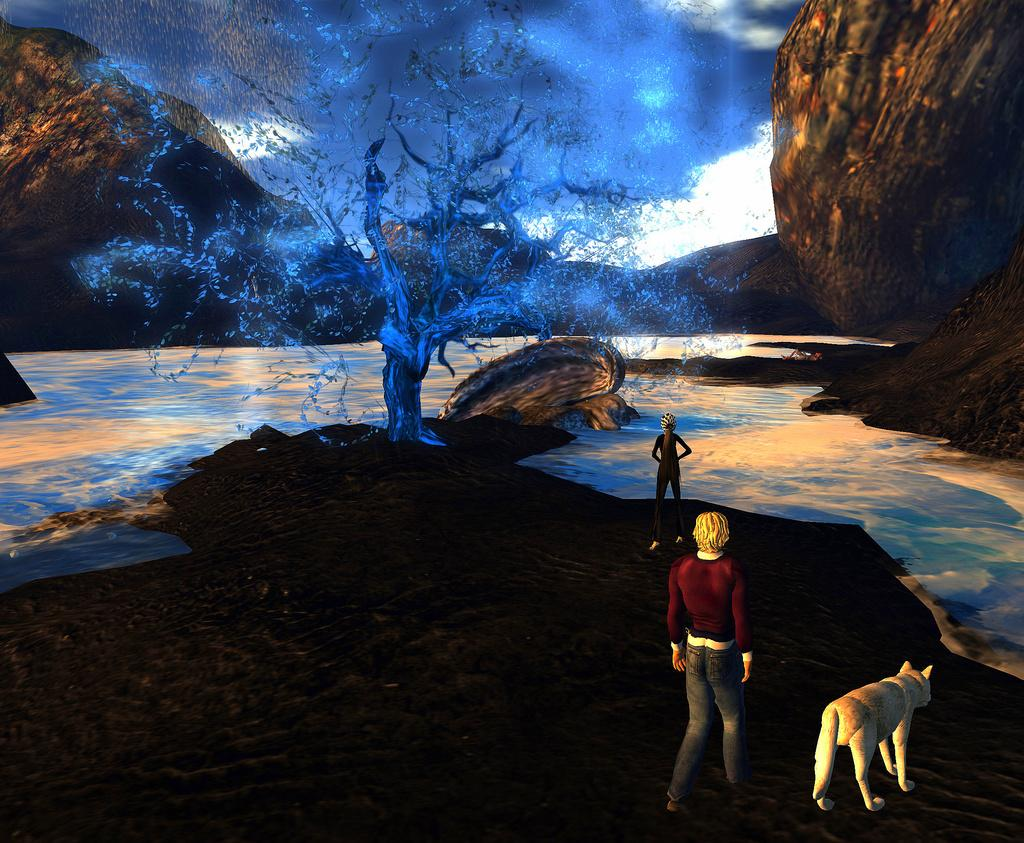How many subjects are present in the image? There are people and an animal in the image, making a total of two subjects. What is the setting of the image? The people and animal are standing on the ground, and there is a tree, water, and a mountain in the image. What type of animal can be seen in the image? The animal in the image is not specified, but it is present along with the people. What type of detail can be seen on the front of the animal in the image? There is no information about the animal's front or any specific details on it in the image. 